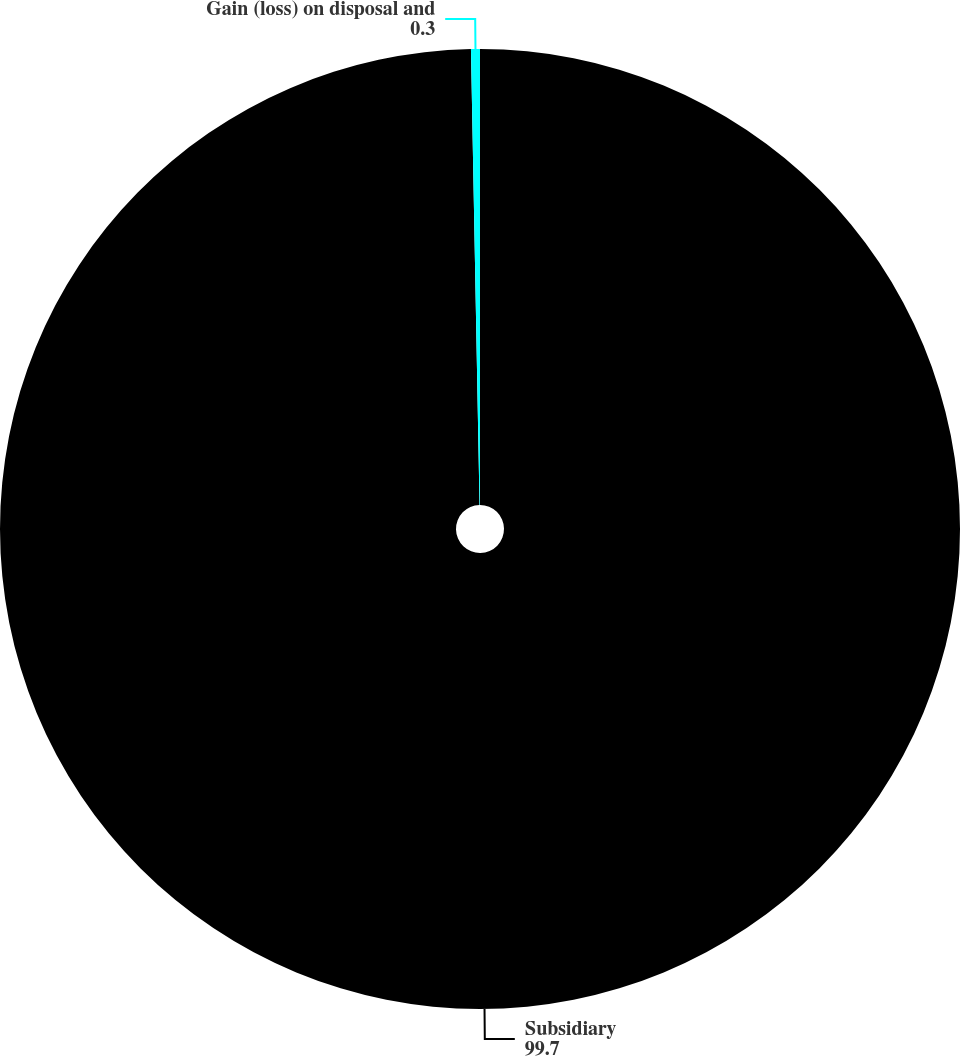Convert chart to OTSL. <chart><loc_0><loc_0><loc_500><loc_500><pie_chart><fcel>Subsidiary<fcel>Gain (loss) on disposal and<nl><fcel>99.7%<fcel>0.3%<nl></chart> 